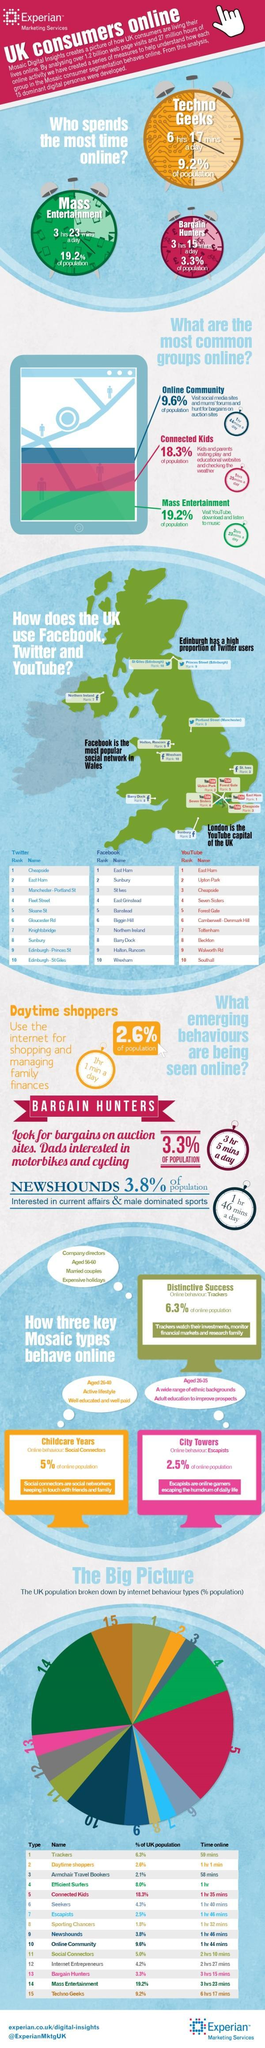Which mosaic type behavior is visualized in the third graphic in this infographic?
Answer the question with a short phrase. Escapists What is the third emerging behavior seen online? Newshounds Which color is used to represent the second most common group online-blue, green, or red? red What is the second emerging behavior seen online? Bargain Hunters Which color is used to represent the most common group online-blue, green, or red? green What is the percentage of seekers and escapists taken together? 6.8% 